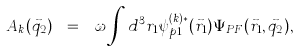Convert formula to latex. <formula><loc_0><loc_0><loc_500><loc_500>A _ { k } ( \vec { q } _ { 2 } ) \ = \ \omega \int d ^ { 3 } r _ { 1 } \psi _ { p 1 } ^ { ( k ) * } ( \vec { r } _ { 1 } ) \Psi _ { P F } ( \vec { r } _ { 1 } , \vec { q } _ { 2 } ) ,</formula> 